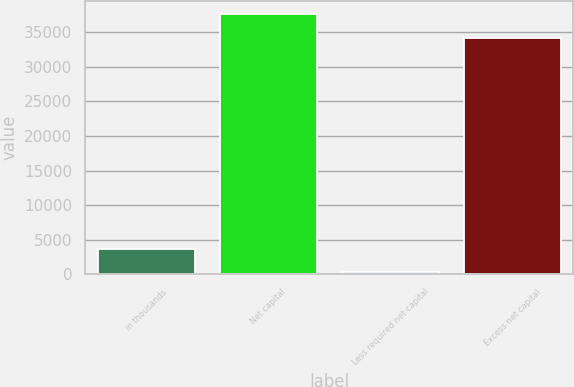Convert chart to OTSL. <chart><loc_0><loc_0><loc_500><loc_500><bar_chart><fcel>in thousands<fcel>Net capital<fcel>Less required net capital<fcel>Excess net capital<nl><fcel>3673.8<fcel>37661.8<fcel>250<fcel>34238<nl></chart> 